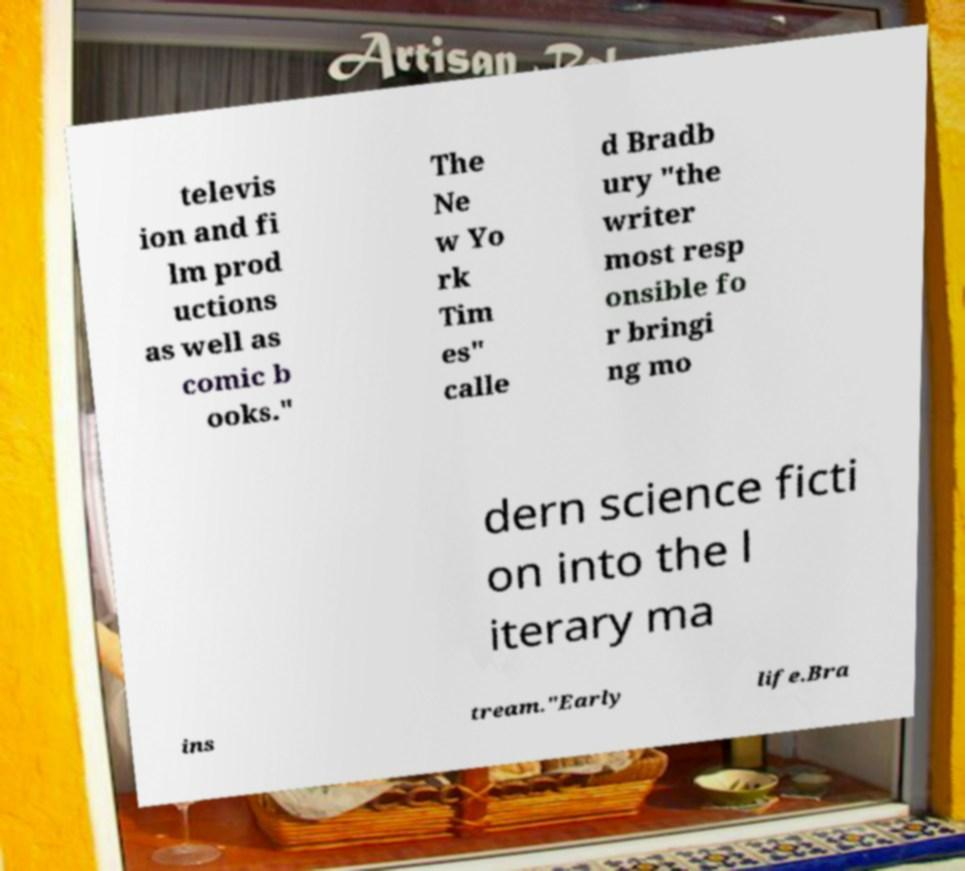Could you assist in decoding the text presented in this image and type it out clearly? televis ion and fi lm prod uctions as well as comic b ooks." The Ne w Yo rk Tim es" calle d Bradb ury "the writer most resp onsible fo r bringi ng mo dern science ficti on into the l iterary ma ins tream."Early life.Bra 